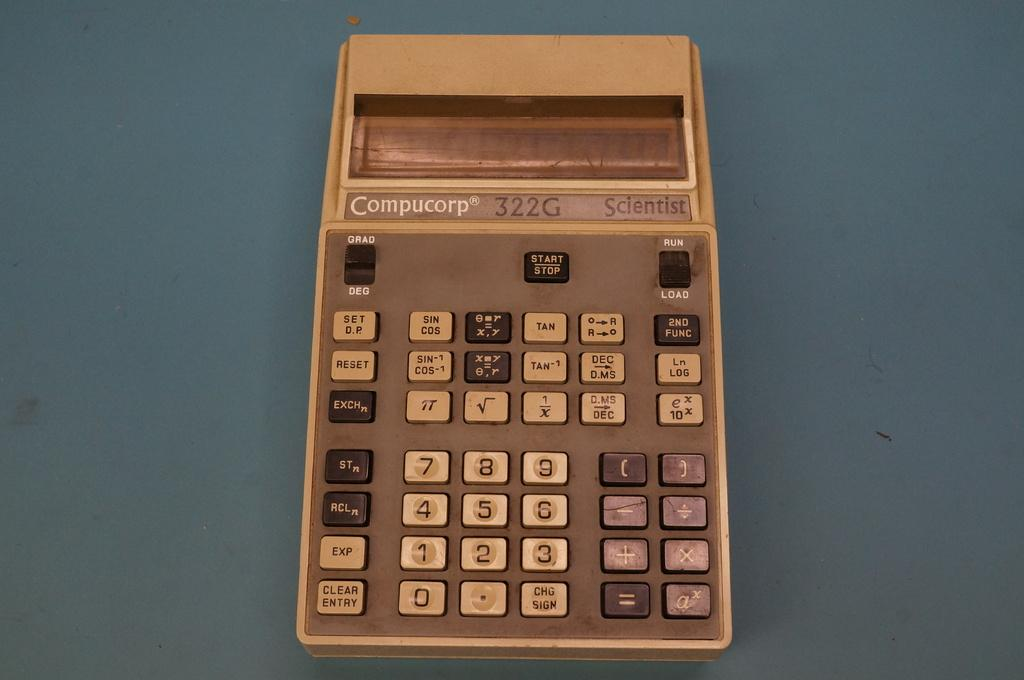<image>
Offer a succinct explanation of the picture presented. An old LCD display Compucorp 322G calculator with dirty buttons. 